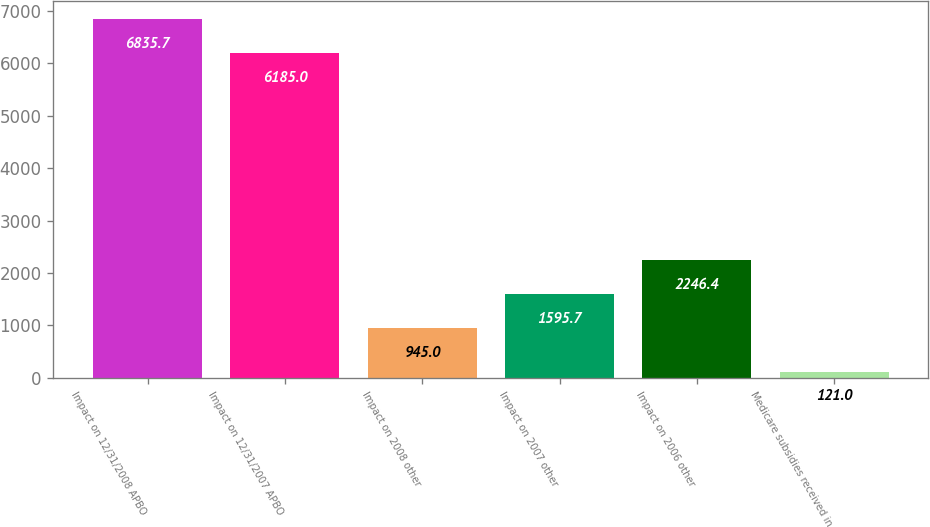Convert chart to OTSL. <chart><loc_0><loc_0><loc_500><loc_500><bar_chart><fcel>Impact on 12/31/2008 APBO<fcel>Impact on 12/31/2007 APBO<fcel>Impact on 2008 other<fcel>Impact on 2007 other<fcel>Impact on 2006 other<fcel>Medicare subsidies received in<nl><fcel>6835.7<fcel>6185<fcel>945<fcel>1595.7<fcel>2246.4<fcel>121<nl></chart> 